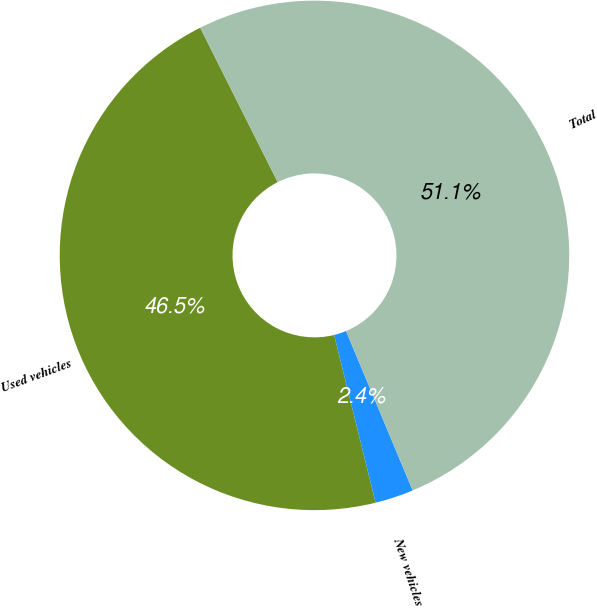<chart> <loc_0><loc_0><loc_500><loc_500><pie_chart><fcel>Used vehicles<fcel>New vehicles<fcel>Total<nl><fcel>46.45%<fcel>2.44%<fcel>51.1%<nl></chart> 